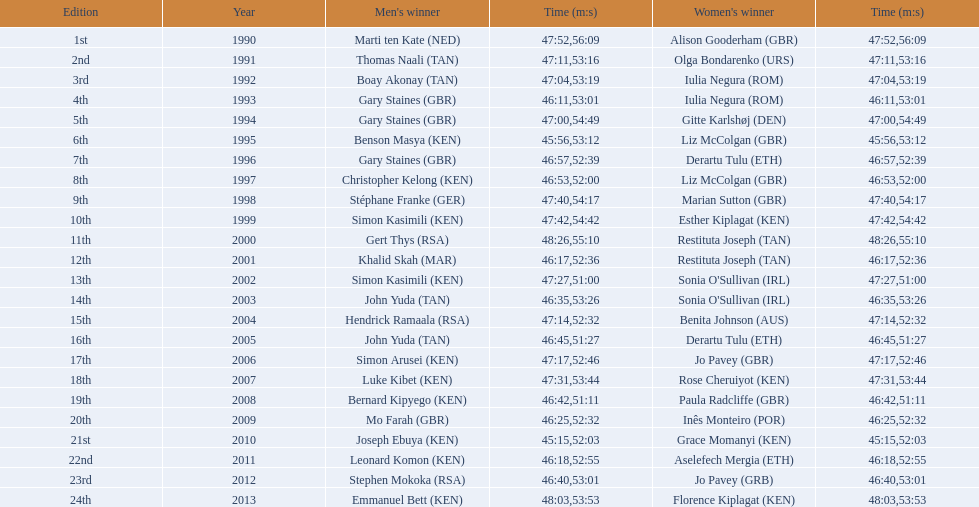I'm looking to parse the entire table for insights. Could you assist me with that? {'header': ['Edition', 'Year', "Men's winner", 'Time (m:s)', "Women's winner", 'Time (m:s)'], 'rows': [['1st', '1990', 'Marti ten Kate\xa0(NED)', '47:52', 'Alison Gooderham\xa0(GBR)', '56:09'], ['2nd', '1991', 'Thomas Naali\xa0(TAN)', '47:11', 'Olga Bondarenko\xa0(URS)', '53:16'], ['3rd', '1992', 'Boay Akonay\xa0(TAN)', '47:04', 'Iulia Negura\xa0(ROM)', '53:19'], ['4th', '1993', 'Gary Staines\xa0(GBR)', '46:11', 'Iulia Negura\xa0(ROM)', '53:01'], ['5th', '1994', 'Gary Staines\xa0(GBR)', '47:00', 'Gitte Karlshøj\xa0(DEN)', '54:49'], ['6th', '1995', 'Benson Masya\xa0(KEN)', '45:56', 'Liz McColgan\xa0(GBR)', '53:12'], ['7th', '1996', 'Gary Staines\xa0(GBR)', '46:57', 'Derartu Tulu\xa0(ETH)', '52:39'], ['8th', '1997', 'Christopher Kelong\xa0(KEN)', '46:53', 'Liz McColgan\xa0(GBR)', '52:00'], ['9th', '1998', 'Stéphane Franke\xa0(GER)', '47:40', 'Marian Sutton\xa0(GBR)', '54:17'], ['10th', '1999', 'Simon Kasimili\xa0(KEN)', '47:42', 'Esther Kiplagat\xa0(KEN)', '54:42'], ['11th', '2000', 'Gert Thys\xa0(RSA)', '48:26', 'Restituta Joseph\xa0(TAN)', '55:10'], ['12th', '2001', 'Khalid Skah\xa0(MAR)', '46:17', 'Restituta Joseph\xa0(TAN)', '52:36'], ['13th', '2002', 'Simon Kasimili\xa0(KEN)', '47:27', "Sonia O'Sullivan\xa0(IRL)", '51:00'], ['14th', '2003', 'John Yuda\xa0(TAN)', '46:35', "Sonia O'Sullivan\xa0(IRL)", '53:26'], ['15th', '2004', 'Hendrick Ramaala\xa0(RSA)', '47:14', 'Benita Johnson\xa0(AUS)', '52:32'], ['16th', '2005', 'John Yuda\xa0(TAN)', '46:45', 'Derartu Tulu\xa0(ETH)', '51:27'], ['17th', '2006', 'Simon Arusei\xa0(KEN)', '47:17', 'Jo Pavey\xa0(GBR)', '52:46'], ['18th', '2007', 'Luke Kibet\xa0(KEN)', '47:31', 'Rose Cheruiyot\xa0(KEN)', '53:44'], ['19th', '2008', 'Bernard Kipyego\xa0(KEN)', '46:42', 'Paula Radcliffe\xa0(GBR)', '51:11'], ['20th', '2009', 'Mo Farah\xa0(GBR)', '46:25', 'Inês Monteiro\xa0(POR)', '52:32'], ['21st', '2010', 'Joseph Ebuya\xa0(KEN)', '45:15', 'Grace Momanyi\xa0(KEN)', '52:03'], ['22nd', '2011', 'Leonard Komon\xa0(KEN)', '46:18', 'Aselefech Mergia\xa0(ETH)', '52:55'], ['23rd', '2012', 'Stephen Mokoka\xa0(RSA)', '46:40', 'Jo Pavey\xa0(GRB)', '53:01'], ['24th', '2013', 'Emmanuel Bett\xa0(KEN)', '48:03', 'Florence Kiplagat\xa0(KEN)', '53:53']]} Who is the male winner listed before gert thys? Simon Kasimili. 